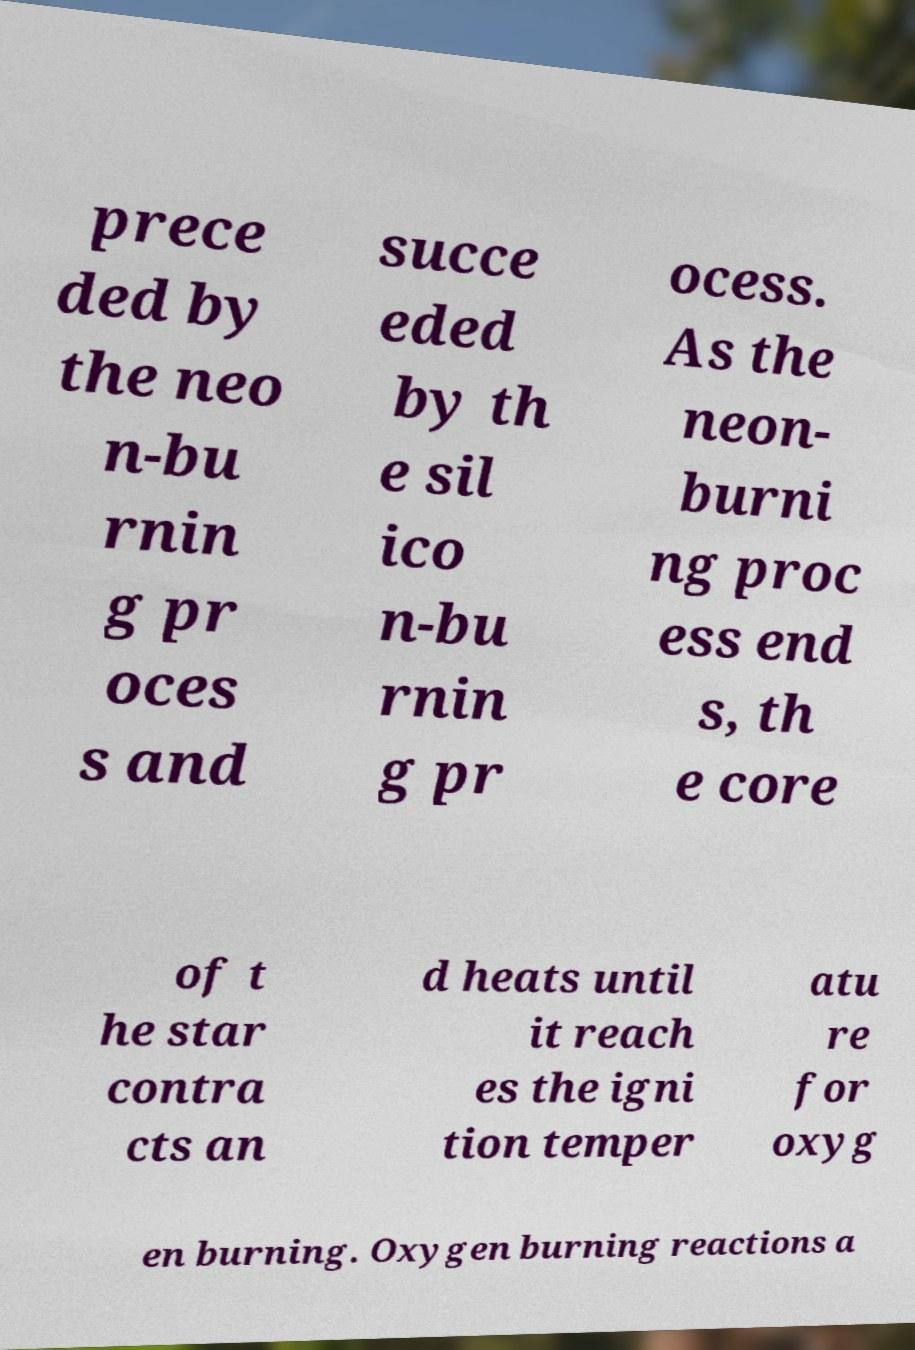What messages or text are displayed in this image? I need them in a readable, typed format. prece ded by the neo n-bu rnin g pr oces s and succe eded by th e sil ico n-bu rnin g pr ocess. As the neon- burni ng proc ess end s, th e core of t he star contra cts an d heats until it reach es the igni tion temper atu re for oxyg en burning. Oxygen burning reactions a 